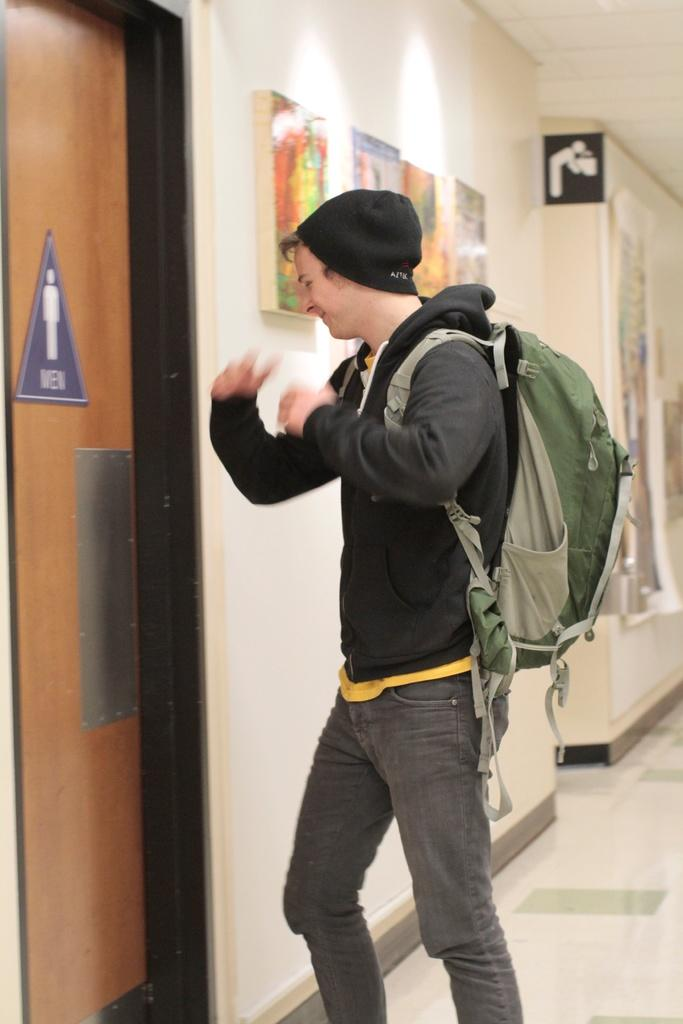What is the man in the image doing? The man is standing in the image. What is the man wearing? The man is wearing a bag and cap. Where is the man located in relation to the door? The man is in front of a door. What does the sign on the door indicate? The sign on the door indicates "men." What can be seen in the background of the image? In the background, there is a signboard, a wall, a roof, a floor, and posters. What type of joke is the man telling in the image? There is no indication in the image that the man is telling a joke, so it cannot be determined from the picture. 